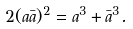Convert formula to latex. <formula><loc_0><loc_0><loc_500><loc_500>2 ( a \bar { a } ) ^ { 2 } = a ^ { 3 } + \bar { a } ^ { 3 } .</formula> 